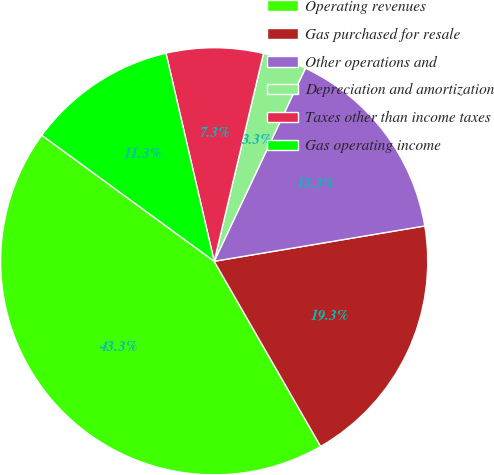<chart> <loc_0><loc_0><loc_500><loc_500><pie_chart><fcel>Operating revenues<fcel>Gas purchased for resale<fcel>Other operations and<fcel>Depreciation and amortization<fcel>Taxes other than income taxes<fcel>Gas operating income<nl><fcel>43.35%<fcel>19.34%<fcel>15.33%<fcel>3.32%<fcel>7.33%<fcel>11.33%<nl></chart> 